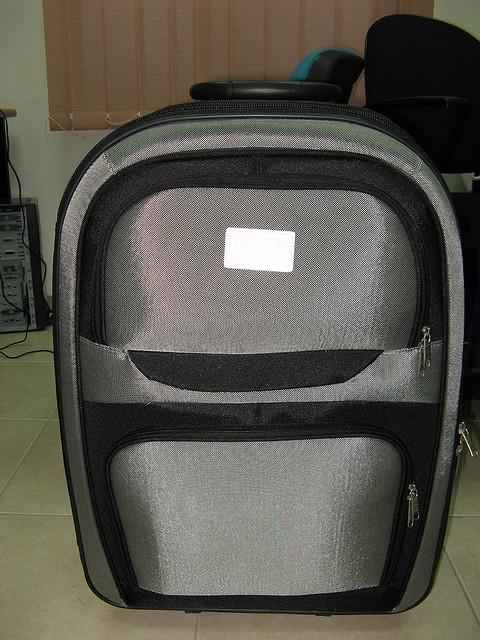What do you do to open this bag?
Concise answer only. Unzip. What type of bag is this?
Quick response, please. Suitcase. What material is the case?
Concise answer only. Nylon. Will this bag fit in an overhead compartment on a plane?
Answer briefly. Yes. 